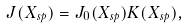Convert formula to latex. <formula><loc_0><loc_0><loc_500><loc_500>J ( X _ { s p } ) = J _ { 0 } ( X _ { s p } ) K ( X _ { s p } ) ,</formula> 